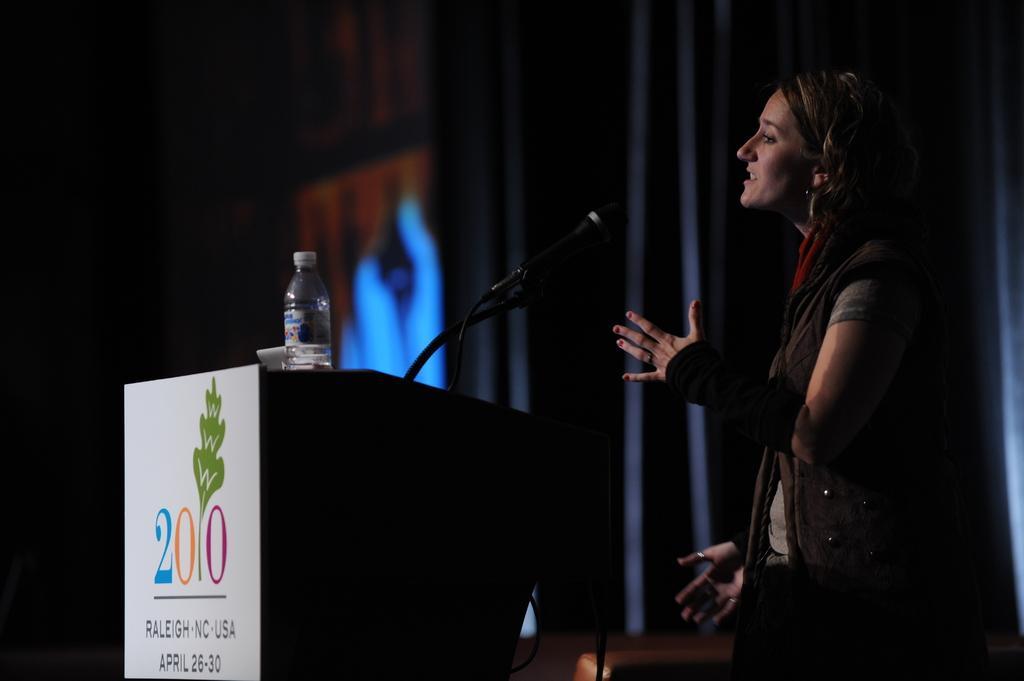Please provide a concise description of this image. In this image I can see the person wearing the dress and standing in-front of the podium. On the podium I can see the mic and bottle. I can see the black, blue and orange color background. 